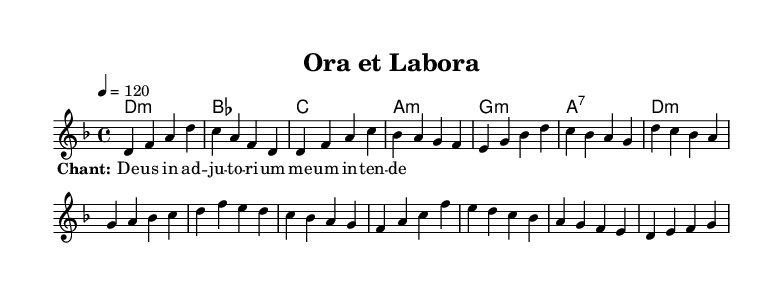What is the key signature of this music? The key signature indicates that the piece is in D minor, which has one flat (B flat). This can be determined by observing the key signature at the beginning of the staff.
Answer: D minor What is the time signature of the piece? The time signature is indicated as 4/4, meaning there are four beats in each measure and a quarter note receives one beat. This is clearly marked at the start of the piece.
Answer: 4/4 What is the tempo marking for this piece? The tempo marking is indicated as "4 = 120", which means that the quarter note is set to 120 beats per minute, guiding the overall speed of the piece. This is evident in the tempo indication at the beginning.
Answer: 120 What is the text of the lyrics used in this composition? The lyrics provided are "Deus in adiutorium meum intende", which is noted below the melody. This is a traditional chant text commonly used in monastic music.
Answer: Deus in adiutorium meum intende Which section of the music is indicated as the chorus? The chorus is specifically marked by the sequence of measures within the given segments of the melody that follow the verse, and it consists of measures 5 to 8. This section typically embodies the main thematic material.
Answer: Chorus (measures 5-8) 